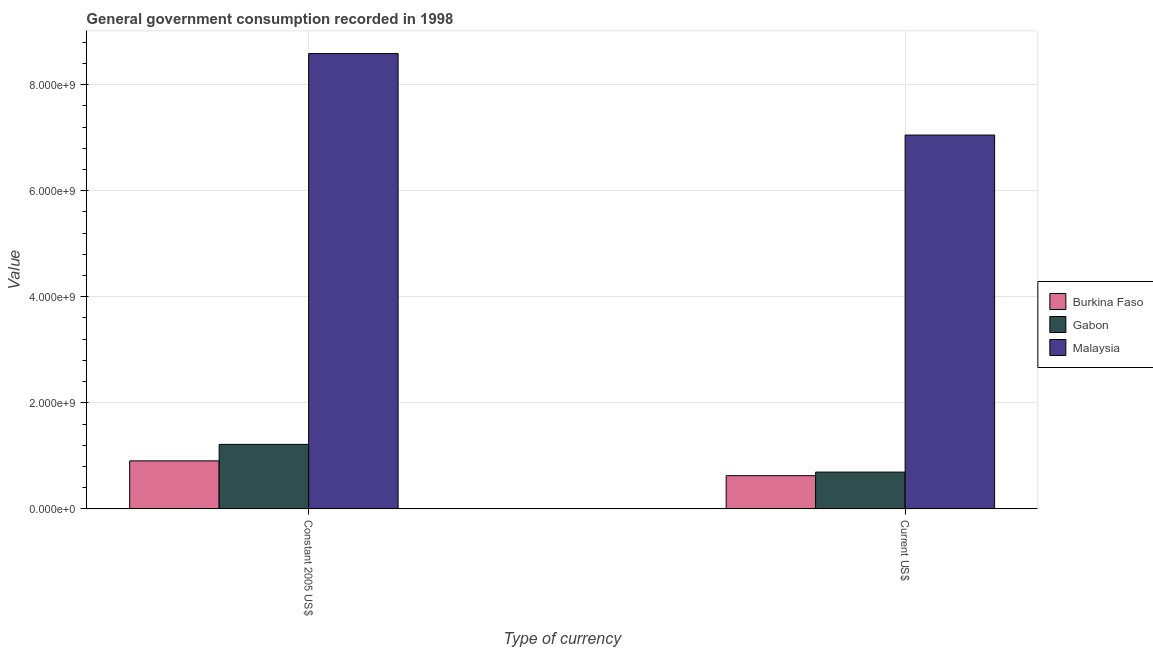Are the number of bars on each tick of the X-axis equal?
Your answer should be compact. Yes. How many bars are there on the 2nd tick from the left?
Offer a terse response. 3. How many bars are there on the 1st tick from the right?
Your answer should be compact. 3. What is the label of the 1st group of bars from the left?
Offer a very short reply. Constant 2005 US$. What is the value consumed in current us$ in Gabon?
Offer a terse response. 6.93e+08. Across all countries, what is the maximum value consumed in current us$?
Your answer should be compact. 7.05e+09. Across all countries, what is the minimum value consumed in current us$?
Offer a terse response. 6.25e+08. In which country was the value consumed in current us$ maximum?
Keep it short and to the point. Malaysia. In which country was the value consumed in constant 2005 us$ minimum?
Provide a succinct answer. Burkina Faso. What is the total value consumed in current us$ in the graph?
Your response must be concise. 8.37e+09. What is the difference between the value consumed in current us$ in Malaysia and that in Gabon?
Provide a succinct answer. 6.36e+09. What is the difference between the value consumed in constant 2005 us$ in Gabon and the value consumed in current us$ in Burkina Faso?
Make the answer very short. 5.90e+08. What is the average value consumed in constant 2005 us$ per country?
Give a very brief answer. 3.57e+09. What is the difference between the value consumed in constant 2005 us$ and value consumed in current us$ in Malaysia?
Your answer should be very brief. 1.54e+09. In how many countries, is the value consumed in current us$ greater than 400000000 ?
Your answer should be very brief. 3. What is the ratio of the value consumed in current us$ in Gabon to that in Burkina Faso?
Your answer should be very brief. 1.11. Is the value consumed in constant 2005 us$ in Malaysia less than that in Burkina Faso?
Keep it short and to the point. No. What does the 3rd bar from the left in Current US$ represents?
Provide a short and direct response. Malaysia. What does the 3rd bar from the right in Constant 2005 US$ represents?
Ensure brevity in your answer.  Burkina Faso. Are all the bars in the graph horizontal?
Give a very brief answer. No. What is the difference between two consecutive major ticks on the Y-axis?
Your response must be concise. 2.00e+09. Are the values on the major ticks of Y-axis written in scientific E-notation?
Make the answer very short. Yes. Where does the legend appear in the graph?
Your response must be concise. Center right. How many legend labels are there?
Offer a terse response. 3. What is the title of the graph?
Give a very brief answer. General government consumption recorded in 1998. Does "Israel" appear as one of the legend labels in the graph?
Provide a succinct answer. No. What is the label or title of the X-axis?
Make the answer very short. Type of currency. What is the label or title of the Y-axis?
Offer a very short reply. Value. What is the Value in Burkina Faso in Constant 2005 US$?
Your answer should be very brief. 9.05e+08. What is the Value of Gabon in Constant 2005 US$?
Your response must be concise. 1.22e+09. What is the Value in Malaysia in Constant 2005 US$?
Provide a short and direct response. 8.59e+09. What is the Value of Burkina Faso in Current US$?
Keep it short and to the point. 6.25e+08. What is the Value of Gabon in Current US$?
Provide a succinct answer. 6.93e+08. What is the Value in Malaysia in Current US$?
Your answer should be compact. 7.05e+09. Across all Type of currency, what is the maximum Value of Burkina Faso?
Your response must be concise. 9.05e+08. Across all Type of currency, what is the maximum Value of Gabon?
Give a very brief answer. 1.22e+09. Across all Type of currency, what is the maximum Value of Malaysia?
Offer a terse response. 8.59e+09. Across all Type of currency, what is the minimum Value of Burkina Faso?
Offer a very short reply. 6.25e+08. Across all Type of currency, what is the minimum Value of Gabon?
Your response must be concise. 6.93e+08. Across all Type of currency, what is the minimum Value of Malaysia?
Make the answer very short. 7.05e+09. What is the total Value in Burkina Faso in the graph?
Provide a short and direct response. 1.53e+09. What is the total Value in Gabon in the graph?
Provide a succinct answer. 1.91e+09. What is the total Value of Malaysia in the graph?
Make the answer very short. 1.56e+1. What is the difference between the Value in Burkina Faso in Constant 2005 US$ and that in Current US$?
Keep it short and to the point. 2.80e+08. What is the difference between the Value of Gabon in Constant 2005 US$ and that in Current US$?
Your response must be concise. 5.22e+08. What is the difference between the Value in Malaysia in Constant 2005 US$ and that in Current US$?
Give a very brief answer. 1.54e+09. What is the difference between the Value in Burkina Faso in Constant 2005 US$ and the Value in Gabon in Current US$?
Your answer should be compact. 2.12e+08. What is the difference between the Value of Burkina Faso in Constant 2005 US$ and the Value of Malaysia in Current US$?
Give a very brief answer. -6.15e+09. What is the difference between the Value of Gabon in Constant 2005 US$ and the Value of Malaysia in Current US$?
Provide a short and direct response. -5.83e+09. What is the average Value in Burkina Faso per Type of currency?
Make the answer very short. 7.65e+08. What is the average Value in Gabon per Type of currency?
Your answer should be very brief. 9.55e+08. What is the average Value in Malaysia per Type of currency?
Your answer should be compact. 7.82e+09. What is the difference between the Value of Burkina Faso and Value of Gabon in Constant 2005 US$?
Ensure brevity in your answer.  -3.11e+08. What is the difference between the Value in Burkina Faso and Value in Malaysia in Constant 2005 US$?
Make the answer very short. -7.68e+09. What is the difference between the Value of Gabon and Value of Malaysia in Constant 2005 US$?
Your answer should be compact. -7.37e+09. What is the difference between the Value of Burkina Faso and Value of Gabon in Current US$?
Your answer should be compact. -6.80e+07. What is the difference between the Value of Burkina Faso and Value of Malaysia in Current US$?
Ensure brevity in your answer.  -6.42e+09. What is the difference between the Value of Gabon and Value of Malaysia in Current US$?
Make the answer very short. -6.36e+09. What is the ratio of the Value in Burkina Faso in Constant 2005 US$ to that in Current US$?
Make the answer very short. 1.45. What is the ratio of the Value in Gabon in Constant 2005 US$ to that in Current US$?
Give a very brief answer. 1.75. What is the ratio of the Value in Malaysia in Constant 2005 US$ to that in Current US$?
Make the answer very short. 1.22. What is the difference between the highest and the second highest Value in Burkina Faso?
Your answer should be compact. 2.80e+08. What is the difference between the highest and the second highest Value in Gabon?
Provide a succinct answer. 5.22e+08. What is the difference between the highest and the second highest Value of Malaysia?
Offer a very short reply. 1.54e+09. What is the difference between the highest and the lowest Value in Burkina Faso?
Keep it short and to the point. 2.80e+08. What is the difference between the highest and the lowest Value of Gabon?
Your answer should be compact. 5.22e+08. What is the difference between the highest and the lowest Value of Malaysia?
Your answer should be compact. 1.54e+09. 